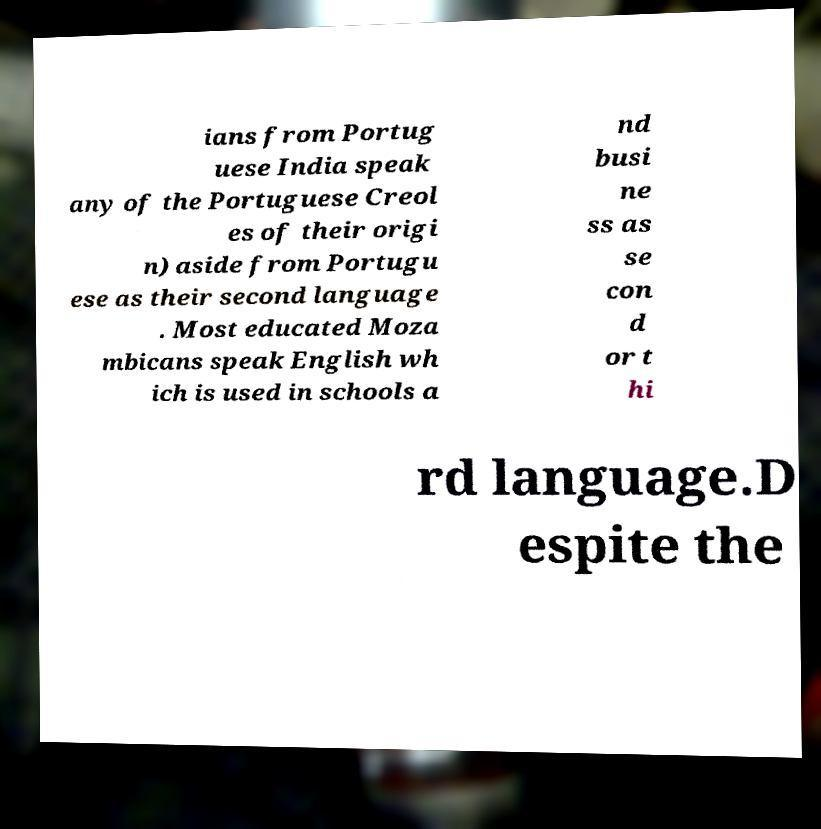For documentation purposes, I need the text within this image transcribed. Could you provide that? ians from Portug uese India speak any of the Portuguese Creol es of their origi n) aside from Portugu ese as their second language . Most educated Moza mbicans speak English wh ich is used in schools a nd busi ne ss as se con d or t hi rd language.D espite the 